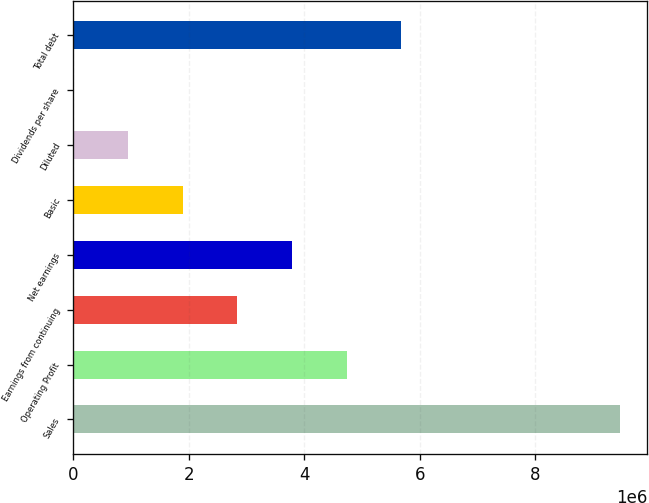<chart> <loc_0><loc_0><loc_500><loc_500><bar_chart><fcel>Sales<fcel>Operating Profit<fcel>Earnings from continuing<fcel>Net earnings<fcel>Basic<fcel>Diluted<fcel>Dividends per share<fcel>Total debt<nl><fcel>9.46606e+06<fcel>4.73303e+06<fcel>2.83982e+06<fcel>3.78642e+06<fcel>1.89321e+06<fcel>946606<fcel>0.08<fcel>5.67963e+06<nl></chart> 